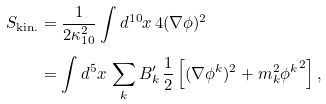Convert formula to latex. <formula><loc_0><loc_0><loc_500><loc_500>S _ { \text {kin.} } & = \frac { 1 } { 2 \kappa _ { 1 0 } ^ { 2 } } \int d ^ { 1 0 } x \, 4 ( \nabla \phi ) ^ { 2 } \\ & = \int d ^ { 5 } x \, \sum _ { k } B ^ { \prime } _ { k } \, \frac { 1 } { 2 } \left [ ( \nabla \phi ^ { k } ) ^ { 2 } + m _ { k } ^ { 2 } { \phi ^ { k } } ^ { 2 } \right ] ,</formula> 